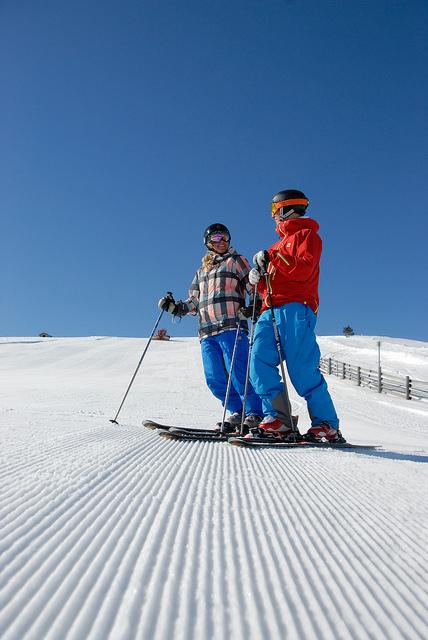Are there clouds here?
Give a very brief answer. No. How many skiers on this hill?
Be succinct. 2. What color are the pants of the skiers?
Keep it brief. Blue. 